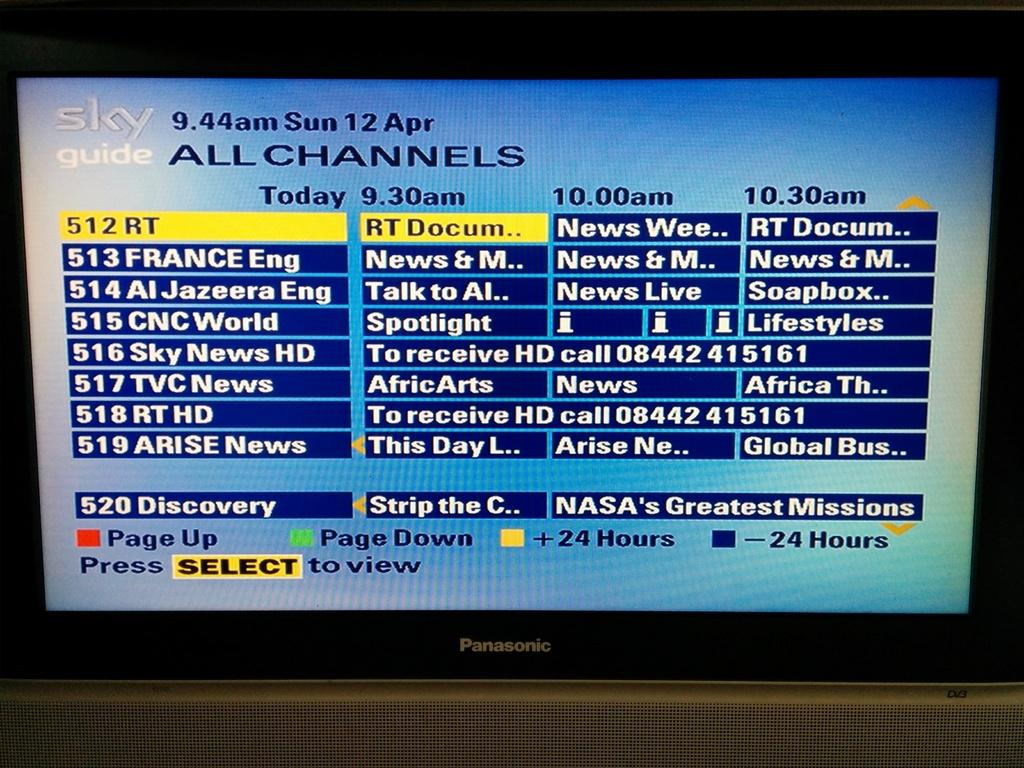<image>
Provide a brief description of the given image. a panasonice tv with sky tv guide page on it. 